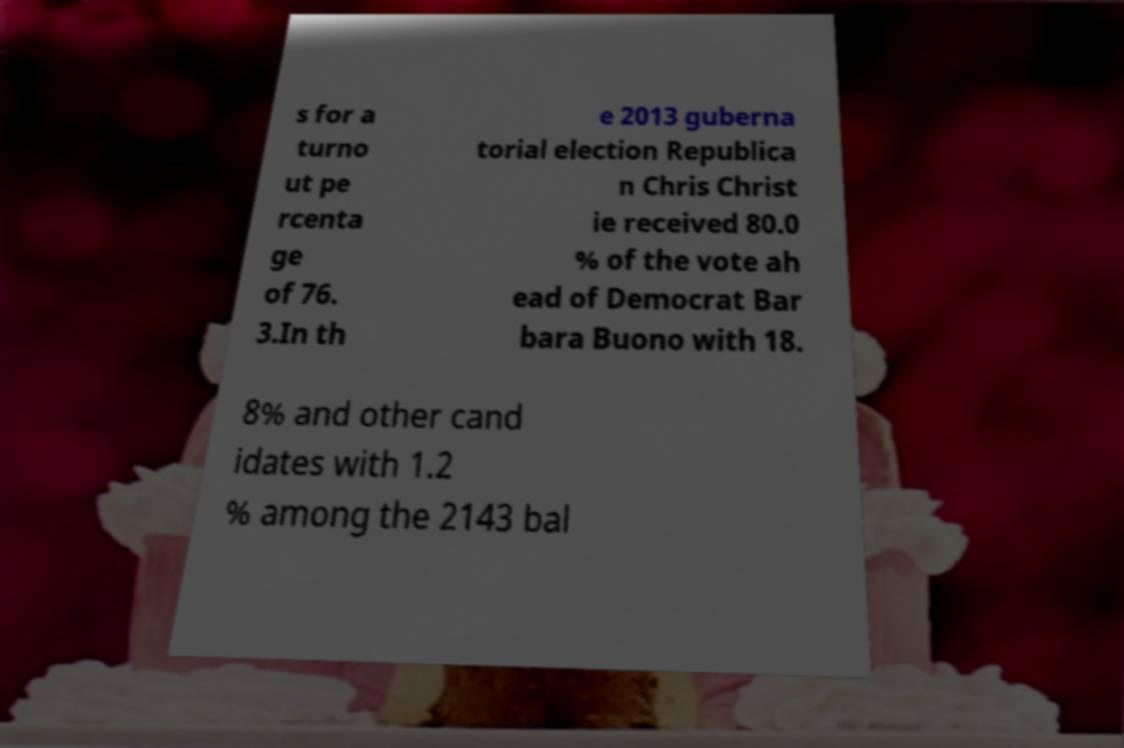Could you assist in decoding the text presented in this image and type it out clearly? s for a turno ut pe rcenta ge of 76. 3.In th e 2013 guberna torial election Republica n Chris Christ ie received 80.0 % of the vote ah ead of Democrat Bar bara Buono with 18. 8% and other cand idates with 1.2 % among the 2143 bal 